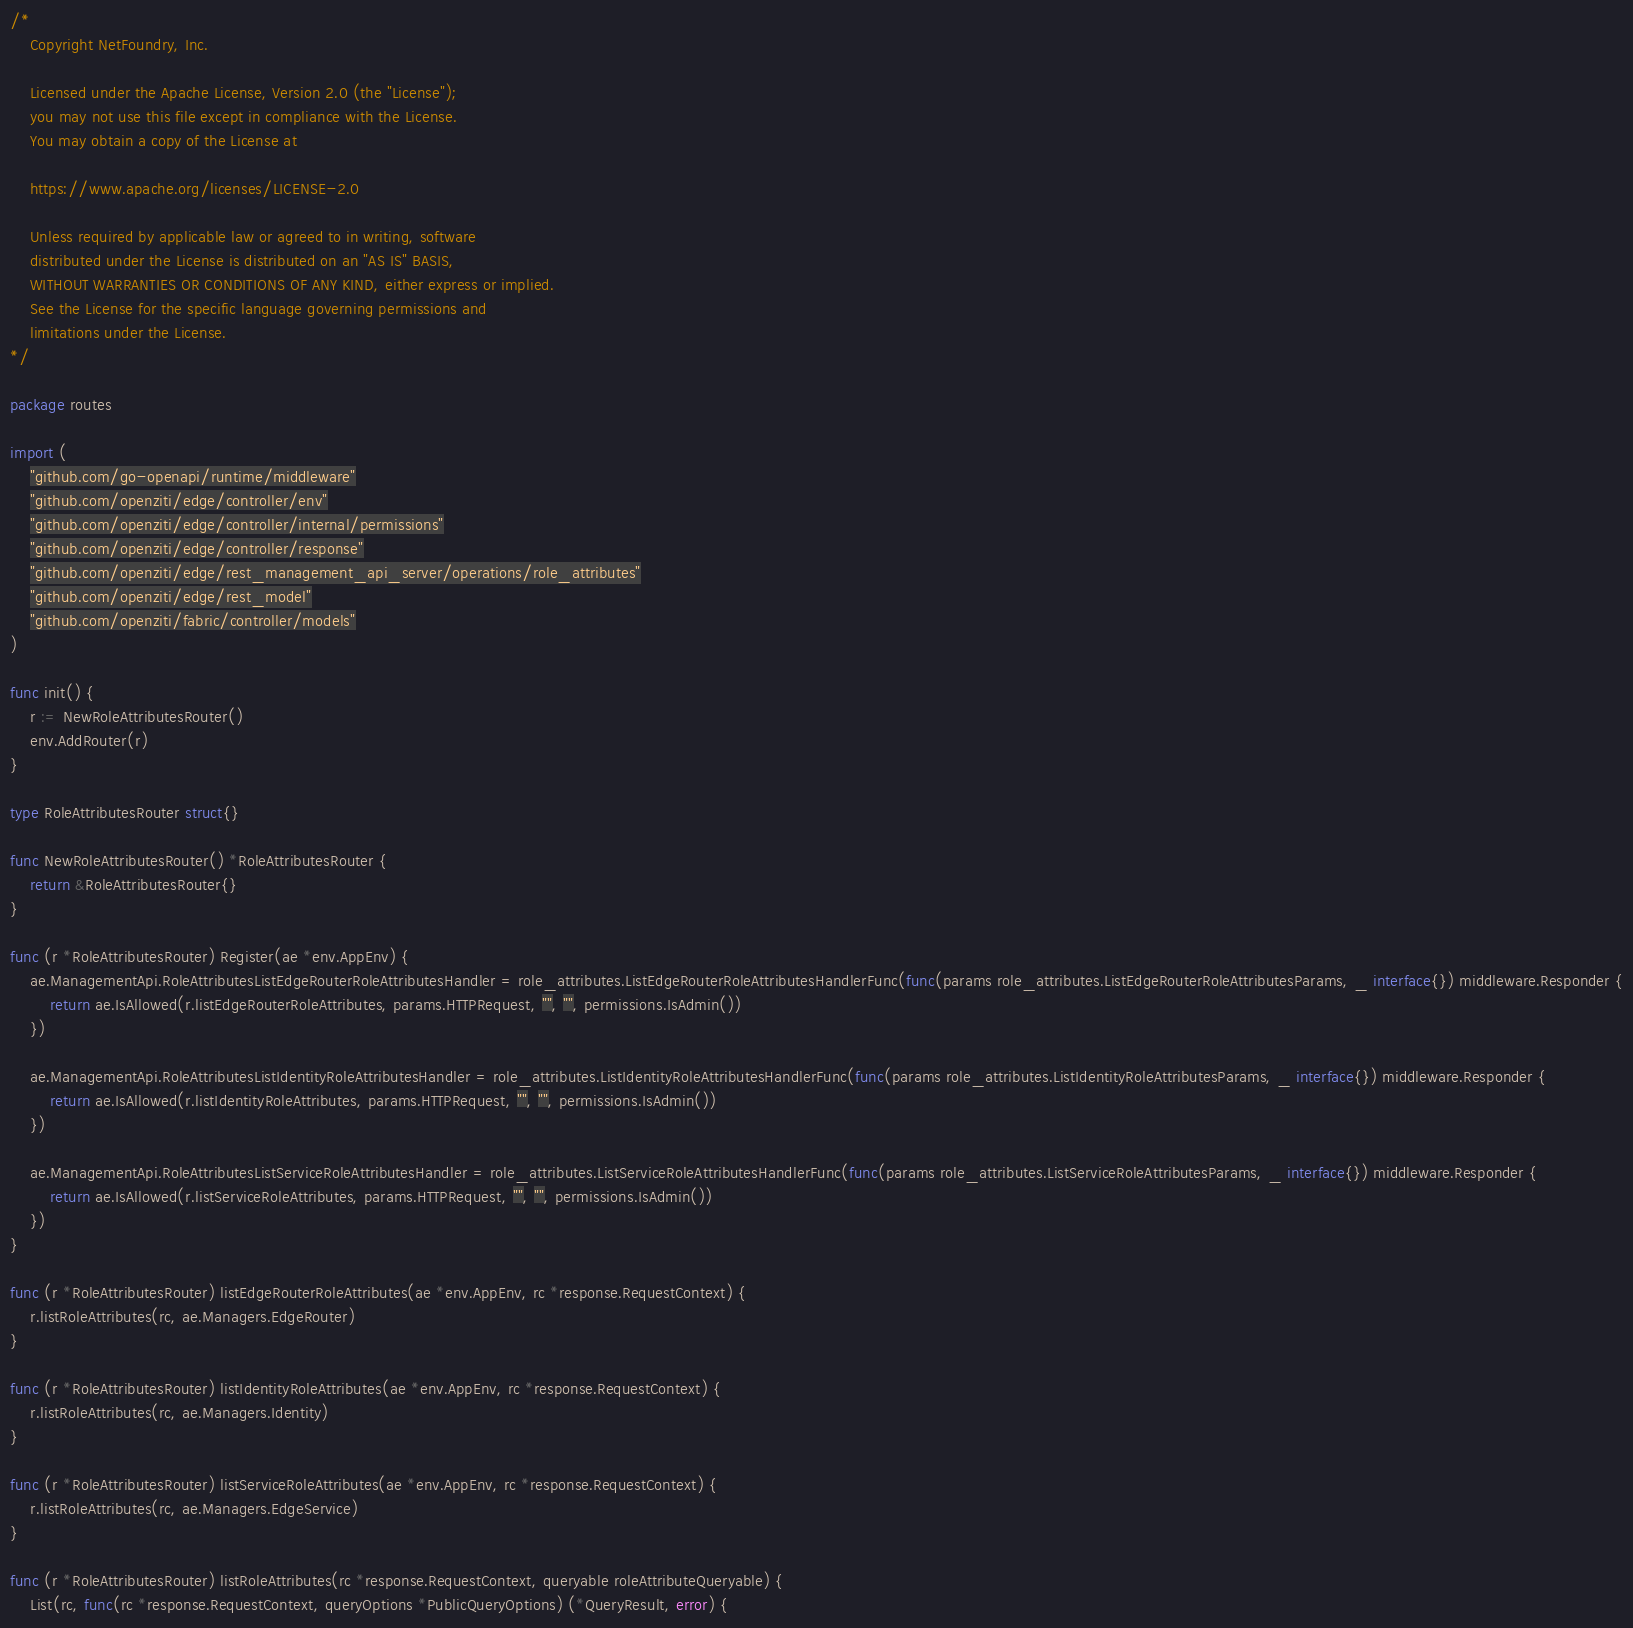<code> <loc_0><loc_0><loc_500><loc_500><_Go_>/*
	Copyright NetFoundry, Inc.

	Licensed under the Apache License, Version 2.0 (the "License");
	you may not use this file except in compliance with the License.
	You may obtain a copy of the License at

	https://www.apache.org/licenses/LICENSE-2.0

	Unless required by applicable law or agreed to in writing, software
	distributed under the License is distributed on an "AS IS" BASIS,
	WITHOUT WARRANTIES OR CONDITIONS OF ANY KIND, either express or implied.
	See the License for the specific language governing permissions and
	limitations under the License.
*/

package routes

import (
	"github.com/go-openapi/runtime/middleware"
	"github.com/openziti/edge/controller/env"
	"github.com/openziti/edge/controller/internal/permissions"
	"github.com/openziti/edge/controller/response"
	"github.com/openziti/edge/rest_management_api_server/operations/role_attributes"
	"github.com/openziti/edge/rest_model"
	"github.com/openziti/fabric/controller/models"
)

func init() {
	r := NewRoleAttributesRouter()
	env.AddRouter(r)
}

type RoleAttributesRouter struct{}

func NewRoleAttributesRouter() *RoleAttributesRouter {
	return &RoleAttributesRouter{}
}

func (r *RoleAttributesRouter) Register(ae *env.AppEnv) {
	ae.ManagementApi.RoleAttributesListEdgeRouterRoleAttributesHandler = role_attributes.ListEdgeRouterRoleAttributesHandlerFunc(func(params role_attributes.ListEdgeRouterRoleAttributesParams, _ interface{}) middleware.Responder {
		return ae.IsAllowed(r.listEdgeRouterRoleAttributes, params.HTTPRequest, "", "", permissions.IsAdmin())
	})

	ae.ManagementApi.RoleAttributesListIdentityRoleAttributesHandler = role_attributes.ListIdentityRoleAttributesHandlerFunc(func(params role_attributes.ListIdentityRoleAttributesParams, _ interface{}) middleware.Responder {
		return ae.IsAllowed(r.listIdentityRoleAttributes, params.HTTPRequest, "", "", permissions.IsAdmin())
	})

	ae.ManagementApi.RoleAttributesListServiceRoleAttributesHandler = role_attributes.ListServiceRoleAttributesHandlerFunc(func(params role_attributes.ListServiceRoleAttributesParams, _ interface{}) middleware.Responder {
		return ae.IsAllowed(r.listServiceRoleAttributes, params.HTTPRequest, "", "", permissions.IsAdmin())
	})
}

func (r *RoleAttributesRouter) listEdgeRouterRoleAttributes(ae *env.AppEnv, rc *response.RequestContext) {
	r.listRoleAttributes(rc, ae.Managers.EdgeRouter)
}

func (r *RoleAttributesRouter) listIdentityRoleAttributes(ae *env.AppEnv, rc *response.RequestContext) {
	r.listRoleAttributes(rc, ae.Managers.Identity)
}

func (r *RoleAttributesRouter) listServiceRoleAttributes(ae *env.AppEnv, rc *response.RequestContext) {
	r.listRoleAttributes(rc, ae.Managers.EdgeService)
}

func (r *RoleAttributesRouter) listRoleAttributes(rc *response.RequestContext, queryable roleAttributeQueryable) {
	List(rc, func(rc *response.RequestContext, queryOptions *PublicQueryOptions) (*QueryResult, error) {</code> 